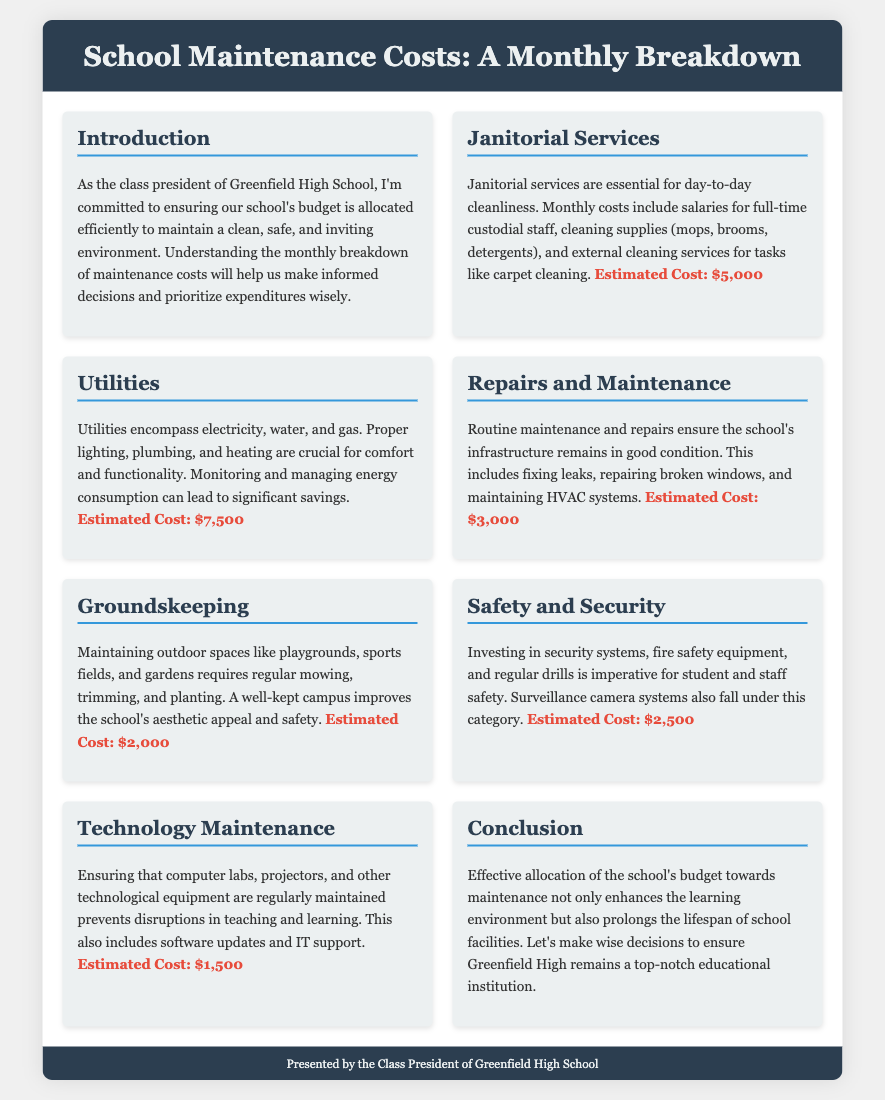What are the estimated costs for janitorial services? The document states that the estimated cost for janitorial services is listed explicitly.
Answer: $5,000 What is included in the utilities expense? Utilities include electricity, water, and gas, which are essential for proper functioning of the school.
Answer: Electricity, water, and gas What is the estimated cost for repairs and maintenance? The estimated cost for repairs and maintenance available in the document can be found under that section.
Answer: $3,000 Which category has the lowest estimated cost? By comparing the estimated costs listed in each section, the lowest cost can be identified.
Answer: Technology Maintenance What is the overall purpose of the document? The document's introduction outlines its main goal related to budget allocation and maintenance.
Answer: Efficient budget allocation How much is budgeted for safety and security? The document provides the estimated budget for safety and security, which can be found in that section.
Answer: $2,500 What should be prioritized based on the maintenance costs? The conclusion suggests what priorities should be highlighted to maintain a good environment for students.
Answer: Maintenance Are external cleaning services part of janitorial costs? The janitorial services section mentions external cleaning services as part of the cost breakdown.
Answer: Yes What does groundskeeping maintain? The document specifies that groundskeeping includes maintenance of playgrounds, sports fields, and gardens.
Answer: Outdoor spaces 